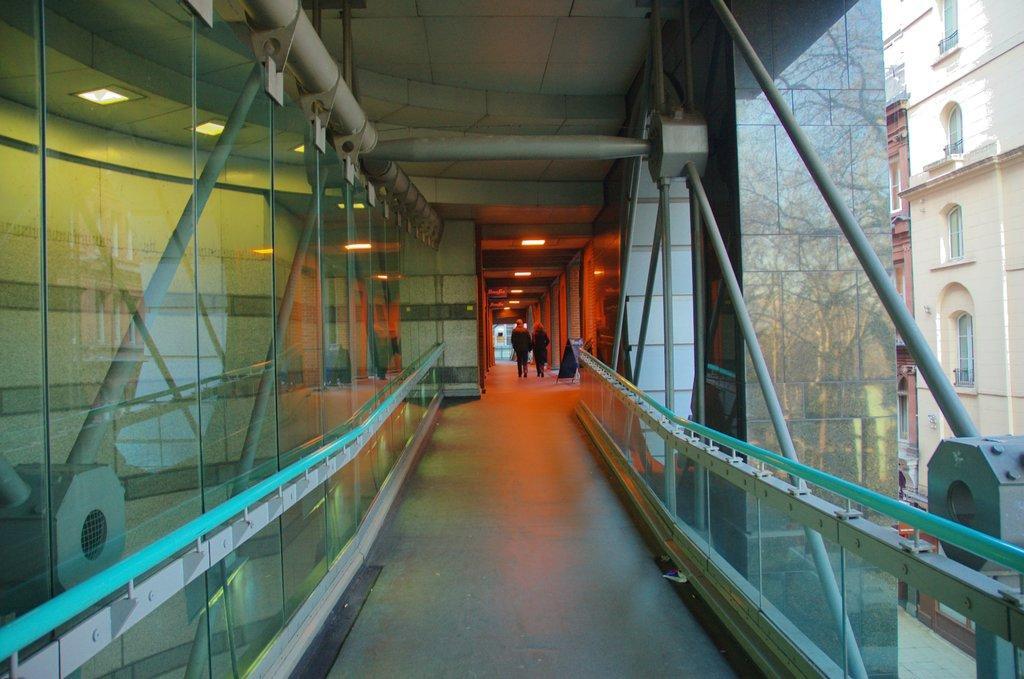In one or two sentences, can you explain what this image depicts? In this image we can see railing, glass objects, metal objects and other objects. In the background of the image there are persons, lights and other objects. On the left side of the image there is the glass. Through the glass we can see lights, wall and other objects. On the right side of the image there is the glass. Through the glass we can see a building, trees and the sky. At the top of the image there is the roof At the bottom of the image there is the floor. 